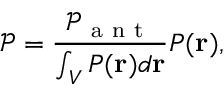Convert formula to latex. <formula><loc_0><loc_0><loc_500><loc_500>\mathcal { P } = \frac { \mathcal { P } _ { a n t } } { \int _ { V } P ( r ) d r } P ( r ) ,</formula> 